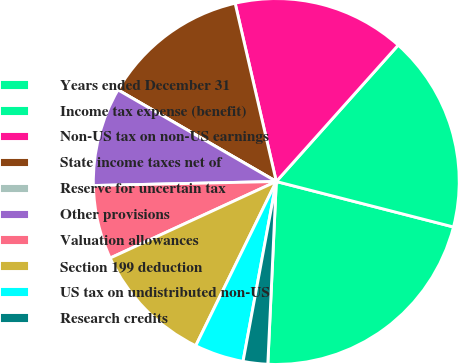Convert chart to OTSL. <chart><loc_0><loc_0><loc_500><loc_500><pie_chart><fcel>Years ended December 31<fcel>Income tax expense (benefit)<fcel>Non-US tax on non-US earnings<fcel>State income taxes net of<fcel>Reserve for uncertain tax<fcel>Other provisions<fcel>Valuation allowances<fcel>Section 199 deduction<fcel>US tax on undistributed non-US<fcel>Research credits<nl><fcel>21.74%<fcel>17.39%<fcel>15.22%<fcel>13.04%<fcel>0.0%<fcel>8.7%<fcel>6.52%<fcel>10.87%<fcel>4.35%<fcel>2.17%<nl></chart> 